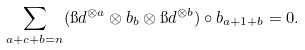Convert formula to latex. <formula><loc_0><loc_0><loc_500><loc_500>\sum _ { a + c + b = n } ( \i d ^ { \otimes a } \otimes b _ { b } \otimes \i d ^ { \otimes b } ) \circ b _ { a + 1 + b } = 0 .</formula> 